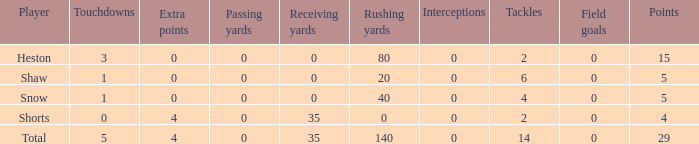What is the total number of field goals a player had when there were more than 0 extra points and there were 5 touchdowns? 1.0. 